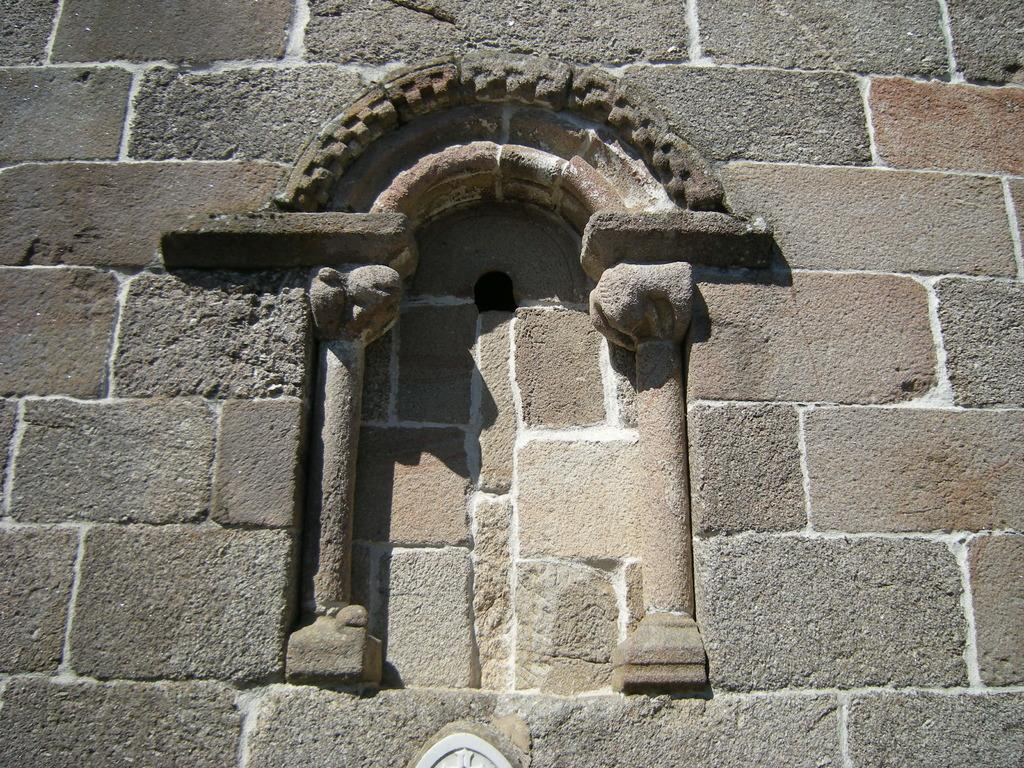What is the main feature in the center of the image? There is an arch in the center of the image. Where is the arch located? The arch is on a wall. How many girls are holding gloves near the arch in the image? There are no girls or gloves present in the image; it only features an arch on a wall. 